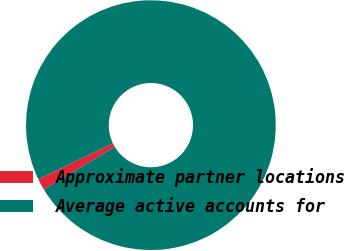<chart> <loc_0><loc_0><loc_500><loc_500><pie_chart><fcel>Approximate partner locations<fcel>Average active accounts for<nl><fcel>1.51%<fcel>98.49%<nl></chart> 